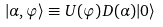Convert formula to latex. <formula><loc_0><loc_0><loc_500><loc_500>| \alpha , \varphi \rangle \equiv U ( \varphi ) D ( \alpha ) | 0 \rangle \\</formula> 